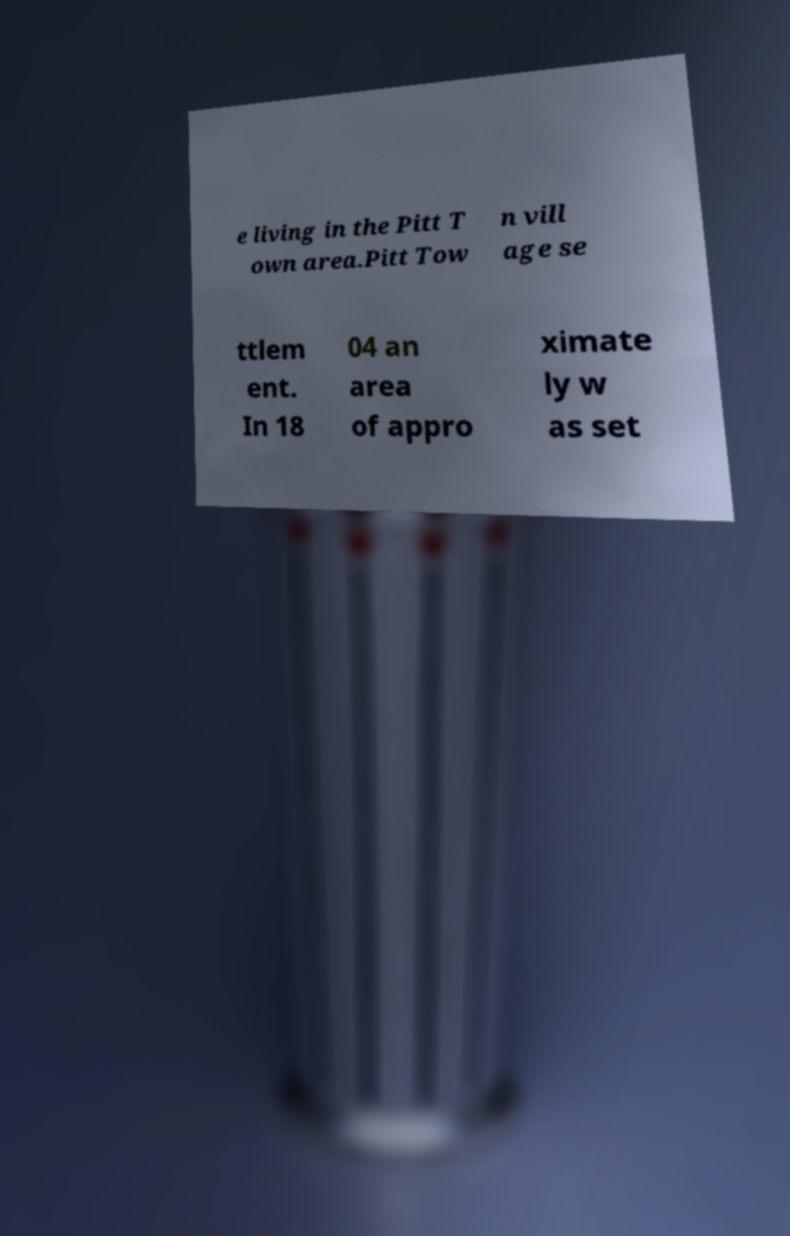Can you accurately transcribe the text from the provided image for me? e living in the Pitt T own area.Pitt Tow n vill age se ttlem ent. In 18 04 an area of appro ximate ly w as set 